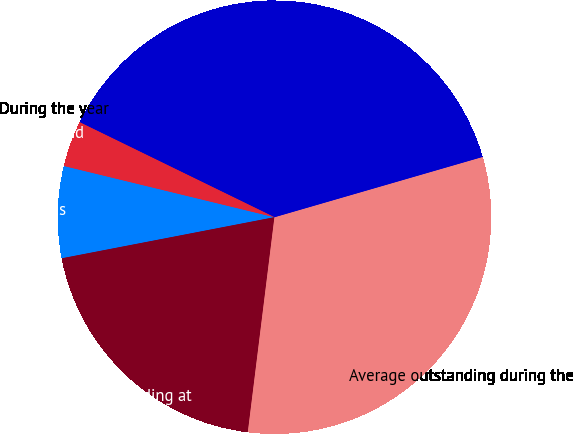Convert chart to OTSL. <chart><loc_0><loc_0><loc_500><loc_500><pie_chart><fcel>in millions<fcel>Amounts outstanding at<fcel>Average outstanding during the<fcel>Maximum month-end outstanding<fcel>During the year<fcel>At year-end<nl><fcel>6.84%<fcel>20.0%<fcel>31.45%<fcel>38.29%<fcel>0.0%<fcel>3.42%<nl></chart> 